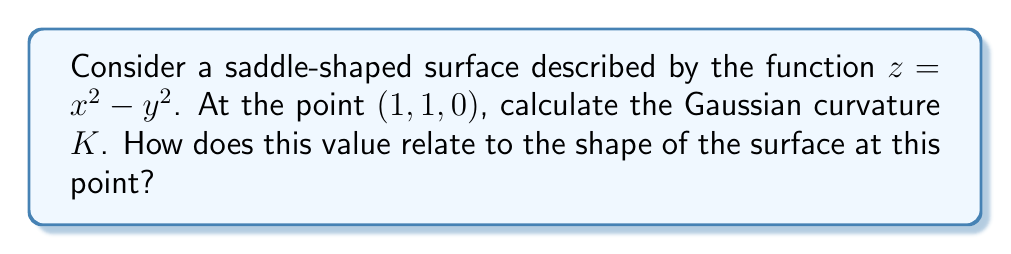Provide a solution to this math problem. Let's approach this step-by-step:

1) The Gaussian curvature K is defined as the product of the principal curvatures: $K = k_1 k_2$

2) For a surface defined by $z = f(x,y)$, we can calculate K using the formula:

   $$K = \frac{f_{xx}f_{yy} - f_{xy}^2}{(1 + f_x^2 + f_y^2)^2}$$

   where subscripts denote partial derivatives.

3) For our surface $z = x^2 - y^2$, let's calculate the required partial derivatives:

   $f_x = 2x$
   $f_y = -2y$
   $f_{xx} = 2$
   $f_{yy} = -2$
   $f_{xy} = 0$

4) At the point (1, 1, 0):

   $f_x = 2$
   $f_y = -2$
   $f_{xx} = 2$
   $f_{yy} = -2$
   $f_{xy} = 0$

5) Substituting into the formula:

   $$K = \frac{(2)(-2) - 0^2}{(1 + 2^2 + (-2)^2)^2} = \frac{-4}{(1 + 4 + 4)^2} = \frac{-4}{81}$$

6) Therefore, the Gaussian curvature at (1, 1, 0) is $K = -\frac{4}{81}$.

7) The negative value of K indicates that the surface has a saddle point at (1, 1, 0). This means the surface curves upward in one direction and downward in the perpendicular direction, which is characteristic of a saddle shape.
Answer: $K = -\frac{4}{81}$; negative, indicating a saddle point 